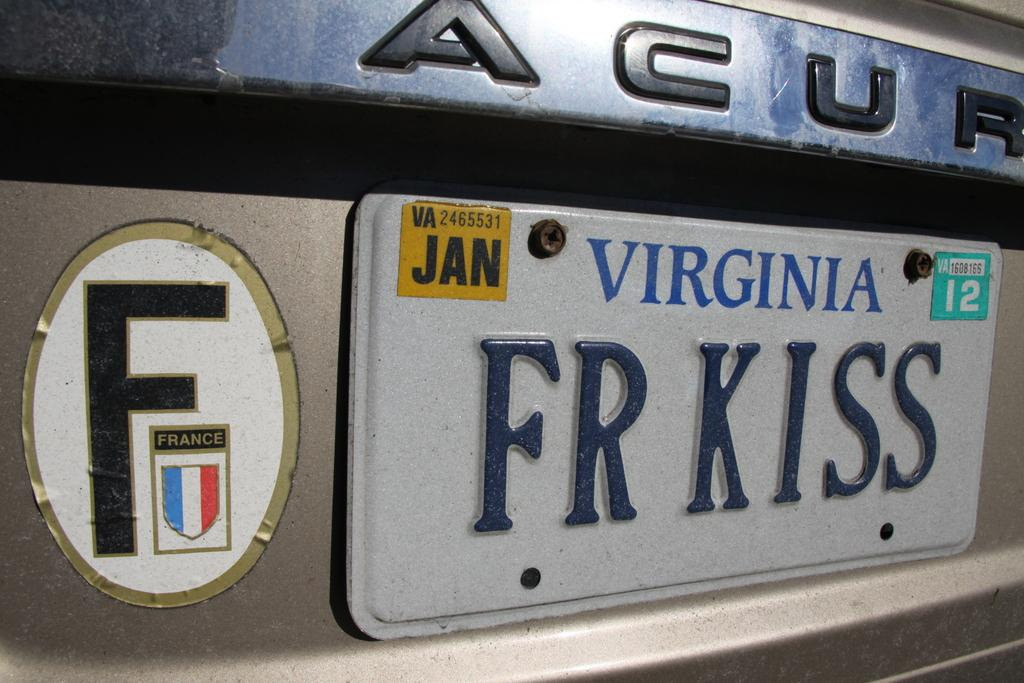<image>
Relay a brief, clear account of the picture shown. The Virginia license plate's meaning is supposed to be french kiss. 